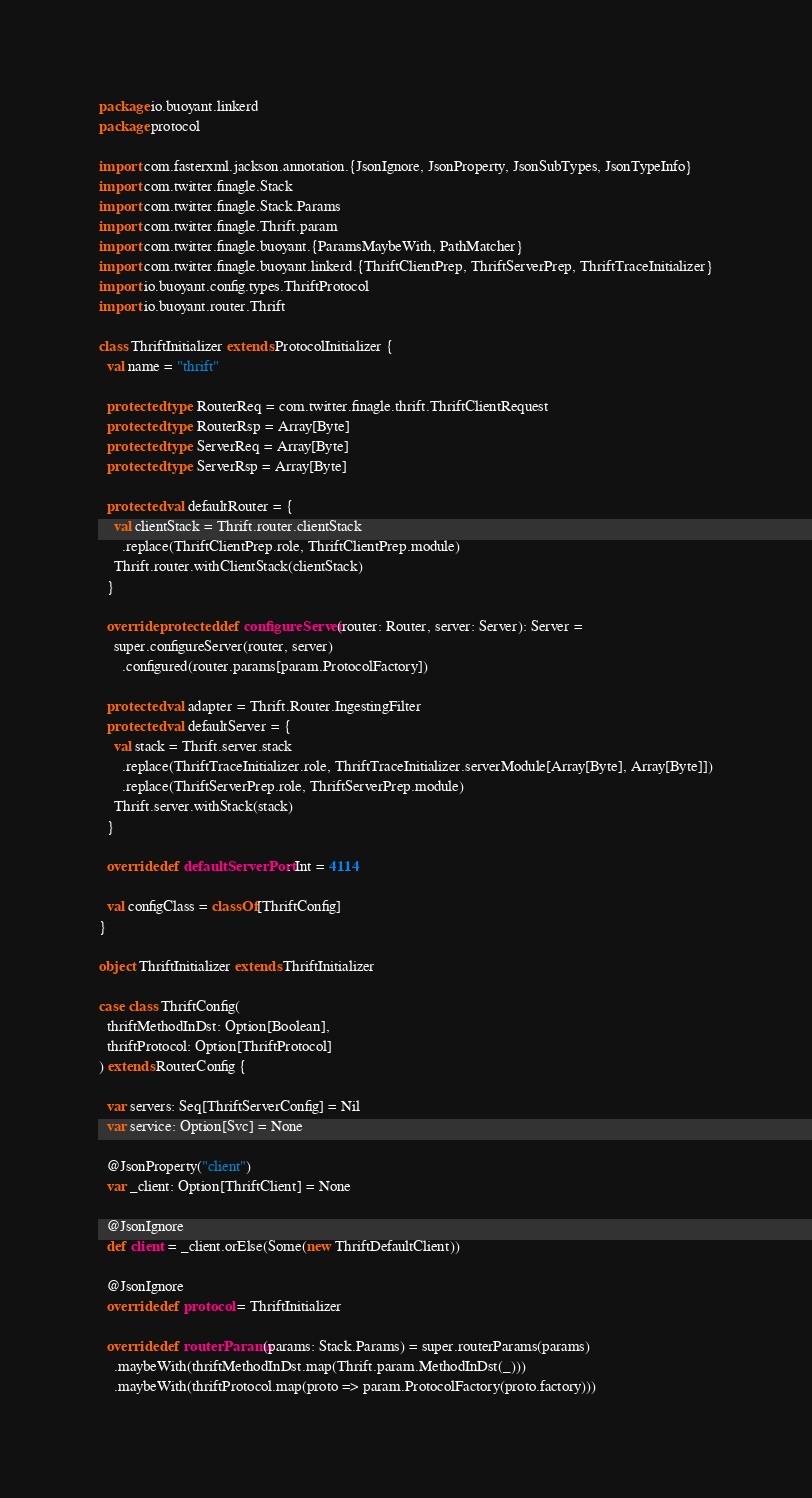Convert code to text. <code><loc_0><loc_0><loc_500><loc_500><_Scala_>package io.buoyant.linkerd
package protocol

import com.fasterxml.jackson.annotation.{JsonIgnore, JsonProperty, JsonSubTypes, JsonTypeInfo}
import com.twitter.finagle.Stack
import com.twitter.finagle.Stack.Params
import com.twitter.finagle.Thrift.param
import com.twitter.finagle.buoyant.{ParamsMaybeWith, PathMatcher}
import com.twitter.finagle.buoyant.linkerd.{ThriftClientPrep, ThriftServerPrep, ThriftTraceInitializer}
import io.buoyant.config.types.ThriftProtocol
import io.buoyant.router.Thrift

class ThriftInitializer extends ProtocolInitializer {
  val name = "thrift"

  protected type RouterReq = com.twitter.finagle.thrift.ThriftClientRequest
  protected type RouterRsp = Array[Byte]
  protected type ServerReq = Array[Byte]
  protected type ServerRsp = Array[Byte]

  protected val defaultRouter = {
    val clientStack = Thrift.router.clientStack
      .replace(ThriftClientPrep.role, ThriftClientPrep.module)
    Thrift.router.withClientStack(clientStack)
  }

  override protected def configureServer(router: Router, server: Server): Server =
    super.configureServer(router, server)
      .configured(router.params[param.ProtocolFactory])

  protected val adapter = Thrift.Router.IngestingFilter
  protected val defaultServer = {
    val stack = Thrift.server.stack
      .replace(ThriftTraceInitializer.role, ThriftTraceInitializer.serverModule[Array[Byte], Array[Byte]])
      .replace(ThriftServerPrep.role, ThriftServerPrep.module)
    Thrift.server.withStack(stack)
  }

  override def defaultServerPort: Int = 4114

  val configClass = classOf[ThriftConfig]
}

object ThriftInitializer extends ThriftInitializer

case class ThriftConfig(
  thriftMethodInDst: Option[Boolean],
  thriftProtocol: Option[ThriftProtocol]
) extends RouterConfig {

  var servers: Seq[ThriftServerConfig] = Nil
  var service: Option[Svc] = None

  @JsonProperty("client")
  var _client: Option[ThriftClient] = None

  @JsonIgnore
  def client = _client.orElse(Some(new ThriftDefaultClient))

  @JsonIgnore
  override def protocol = ThriftInitializer

  override def routerParams(params: Stack.Params) = super.routerParams(params)
    .maybeWith(thriftMethodInDst.map(Thrift.param.MethodInDst(_)))
    .maybeWith(thriftProtocol.map(proto => param.ProtocolFactory(proto.factory)))</code> 